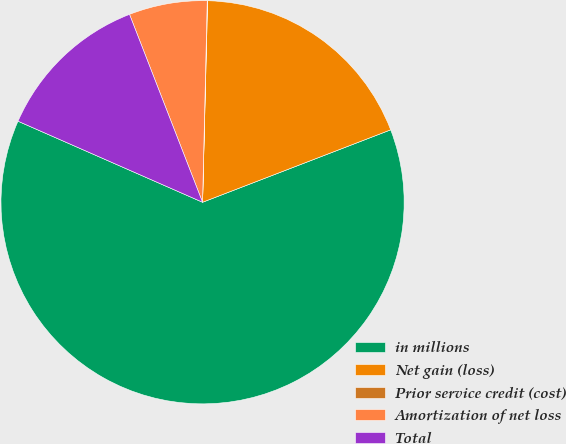Convert chart to OTSL. <chart><loc_0><loc_0><loc_500><loc_500><pie_chart><fcel>in millions<fcel>Net gain (loss)<fcel>Prior service credit (cost)<fcel>Amortization of net loss<fcel>Total<nl><fcel>62.43%<fcel>18.75%<fcel>0.03%<fcel>6.27%<fcel>12.51%<nl></chart> 